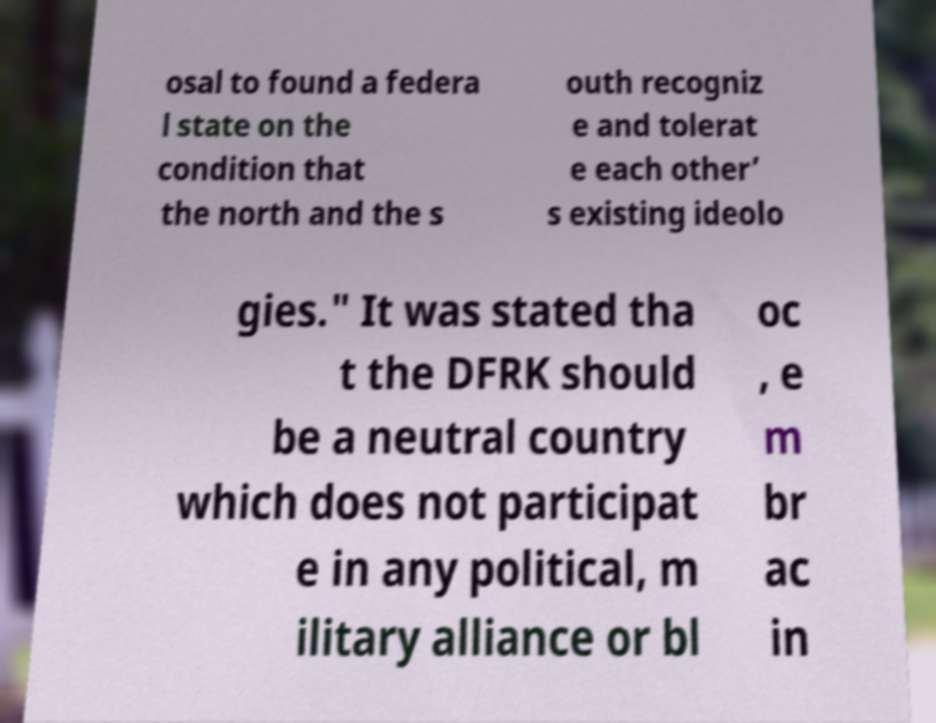Could you assist in decoding the text presented in this image and type it out clearly? osal to found a federa l state on the condition that the north and the s outh recogniz e and tolerat e each other’ s existing ideolo gies." It was stated tha t the DFRK should be a neutral country which does not participat e in any political, m ilitary alliance or bl oc , e m br ac in 